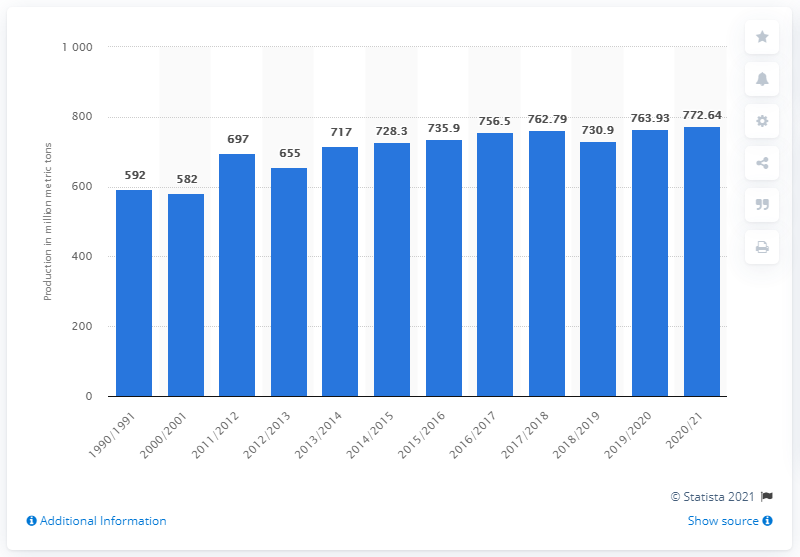Specify some key components in this picture. In the 2019/2020 crop year, the global production of wheat was estimated to be 772.64 million metric tons. 